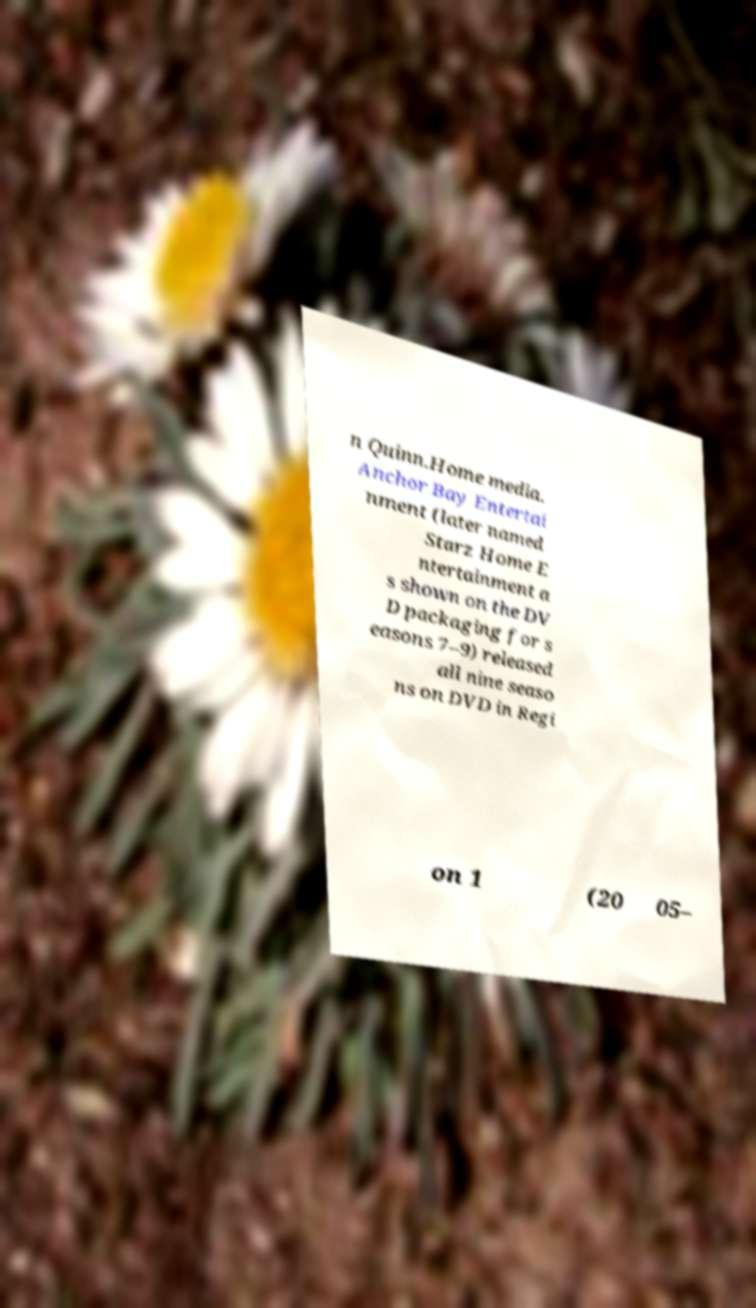Could you assist in decoding the text presented in this image and type it out clearly? n Quinn.Home media. Anchor Bay Entertai nment (later named Starz Home E ntertainment a s shown on the DV D packaging for s easons 7–9) released all nine seaso ns on DVD in Regi on 1 (20 05– 